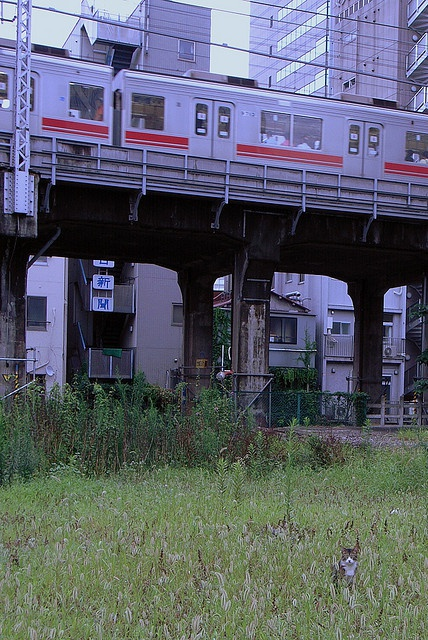Describe the objects in this image and their specific colors. I can see train in gray, violet, purple, and navy tones and cat in gray, darkgray, and black tones in this image. 